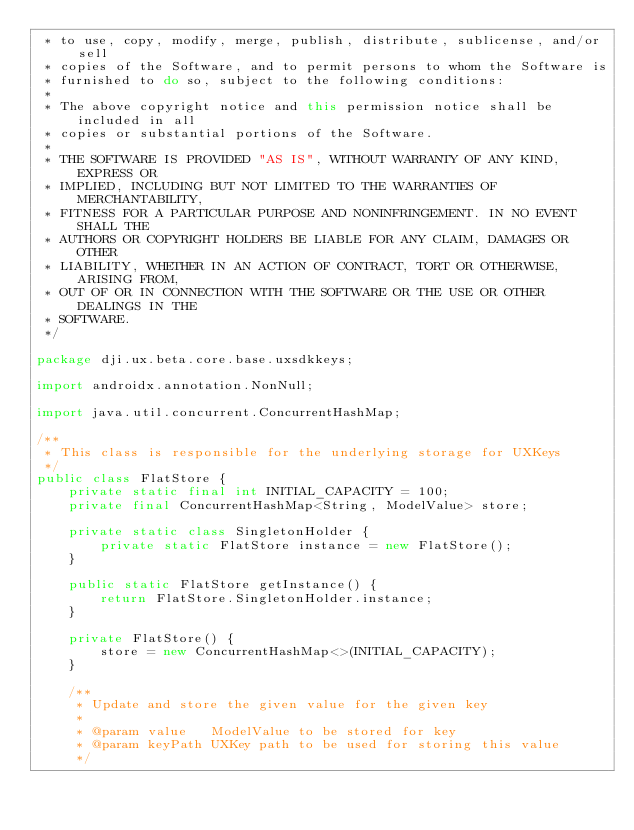Convert code to text. <code><loc_0><loc_0><loc_500><loc_500><_Java_> * to use, copy, modify, merge, publish, distribute, sublicense, and/or sell
 * copies of the Software, and to permit persons to whom the Software is
 * furnished to do so, subject to the following conditions:
 *
 * The above copyright notice and this permission notice shall be included in all
 * copies or substantial portions of the Software.
 *
 * THE SOFTWARE IS PROVIDED "AS IS", WITHOUT WARRANTY OF ANY KIND, EXPRESS OR
 * IMPLIED, INCLUDING BUT NOT LIMITED TO THE WARRANTIES OF MERCHANTABILITY,
 * FITNESS FOR A PARTICULAR PURPOSE AND NONINFRINGEMENT. IN NO EVENT SHALL THE
 * AUTHORS OR COPYRIGHT HOLDERS BE LIABLE FOR ANY CLAIM, DAMAGES OR OTHER
 * LIABILITY, WHETHER IN AN ACTION OF CONTRACT, TORT OR OTHERWISE, ARISING FROM,
 * OUT OF OR IN CONNECTION WITH THE SOFTWARE OR THE USE OR OTHER DEALINGS IN THE
 * SOFTWARE.
 */

package dji.ux.beta.core.base.uxsdkkeys;

import androidx.annotation.NonNull;

import java.util.concurrent.ConcurrentHashMap;

/**
 * This class is responsible for the underlying storage for UXKeys
 */
public class FlatStore {
    private static final int INITIAL_CAPACITY = 100;
    private final ConcurrentHashMap<String, ModelValue> store;

    private static class SingletonHolder {
        private static FlatStore instance = new FlatStore();
    }

    public static FlatStore getInstance() {
        return FlatStore.SingletonHolder.instance;
    }

    private FlatStore() {
        store = new ConcurrentHashMap<>(INITIAL_CAPACITY);
    }

    /**
     * Update and store the given value for the given key
     *
     * @param value   ModelValue to be stored for key
     * @param keyPath UXKey path to be used for storing this value
     */</code> 